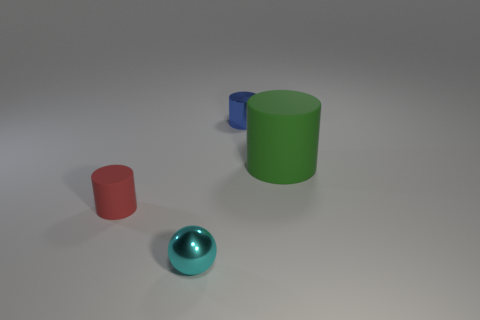Add 2 tiny shiny balls. How many objects exist? 6 Subtract all spheres. How many objects are left? 3 Add 1 red things. How many red things are left? 2 Add 2 tiny purple spheres. How many tiny purple spheres exist? 2 Subtract 0 purple cylinders. How many objects are left? 4 Subtract all balls. Subtract all cylinders. How many objects are left? 0 